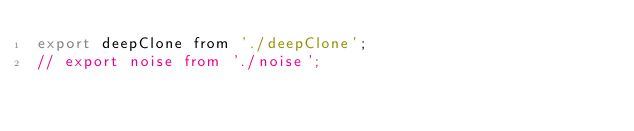<code> <loc_0><loc_0><loc_500><loc_500><_JavaScript_>export deepClone from './deepClone';
// export noise from './noise';
</code> 